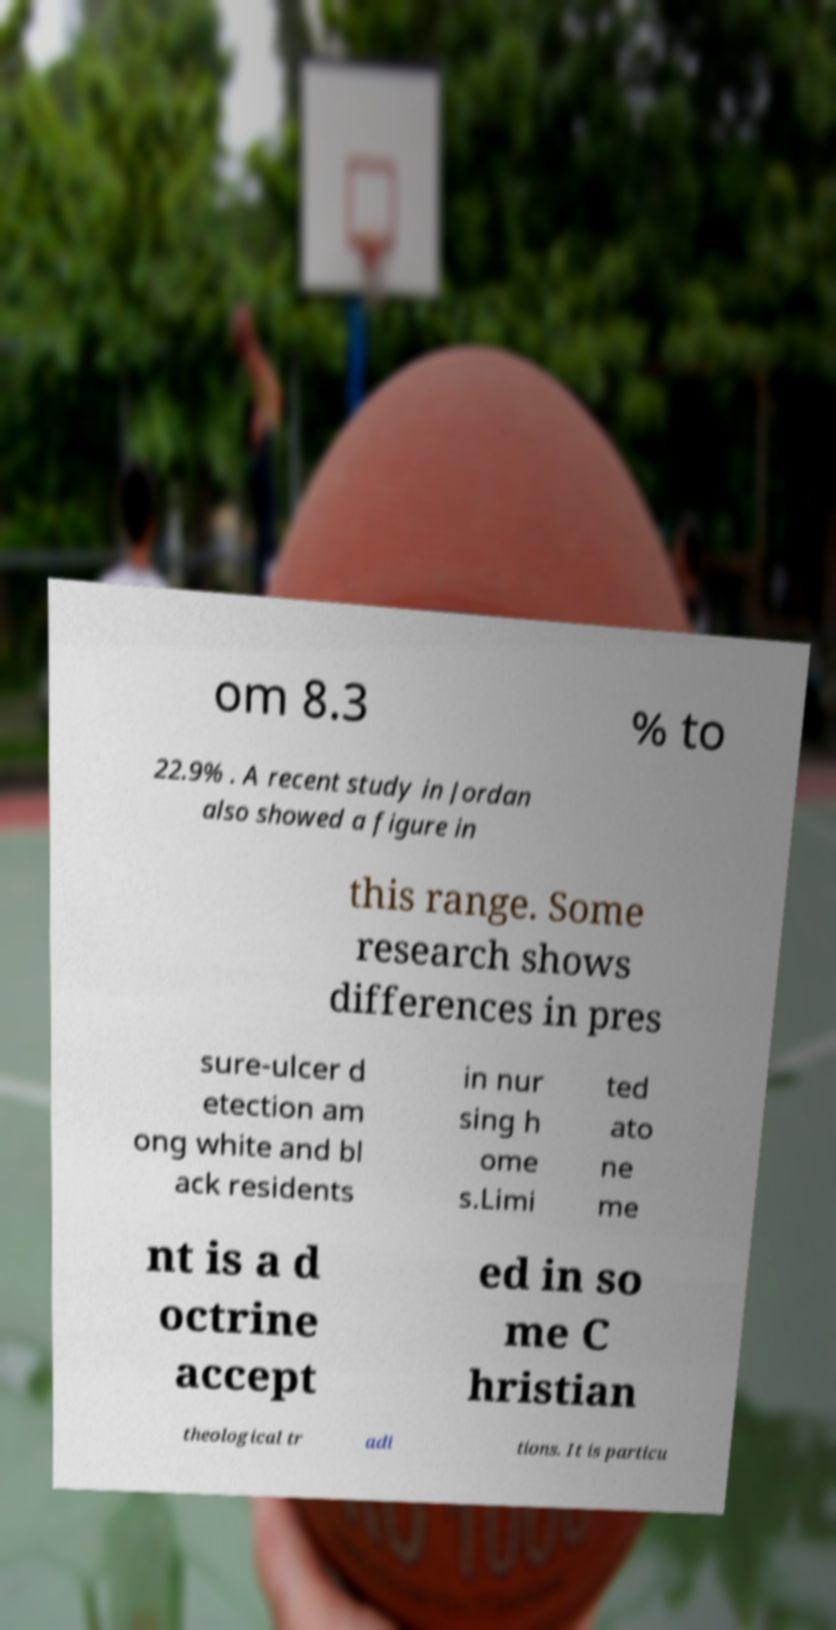For documentation purposes, I need the text within this image transcribed. Could you provide that? om 8.3 % to 22.9% . A recent study in Jordan also showed a figure in this range. Some research shows differences in pres sure-ulcer d etection am ong white and bl ack residents in nur sing h ome s.Limi ted ato ne me nt is a d octrine accept ed in so me C hristian theological tr adi tions. It is particu 